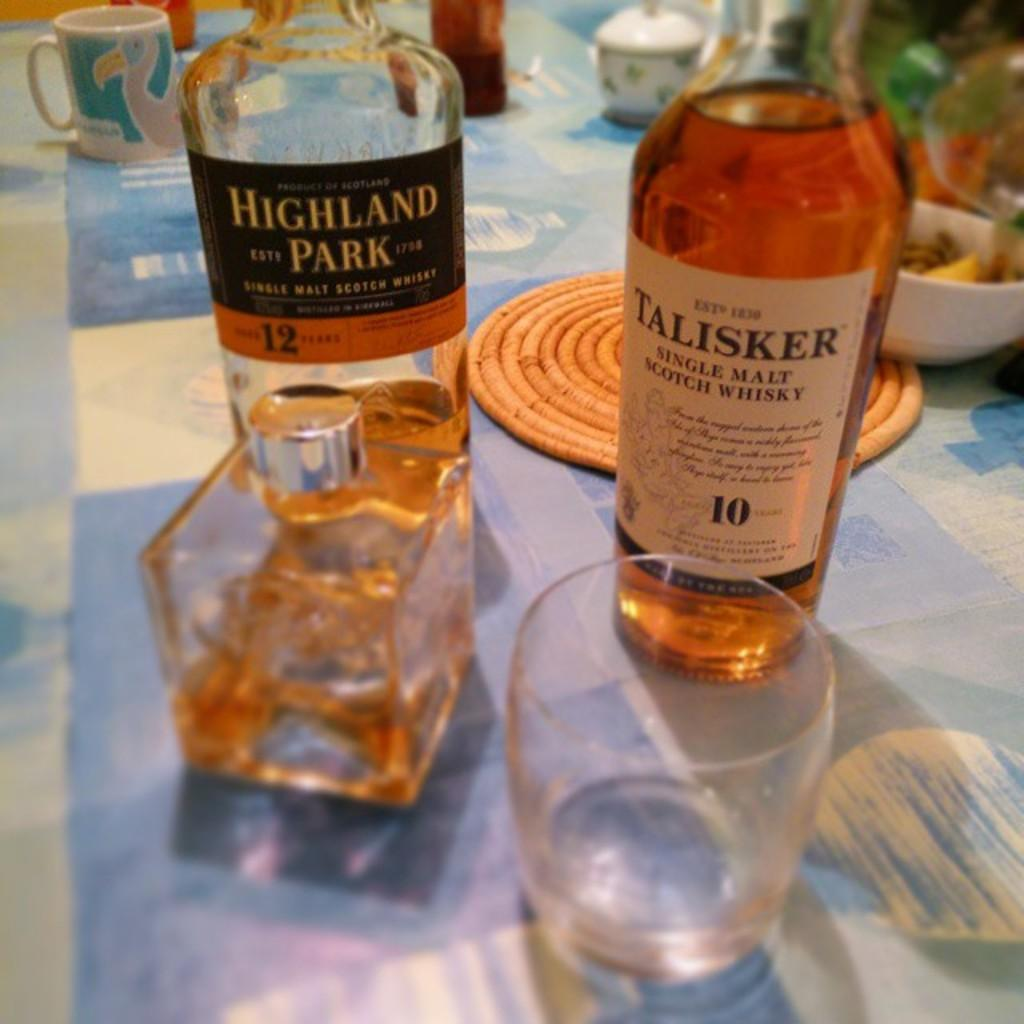<image>
Provide a brief description of the given image. A bottle of Highland Park Malt on a table next to a bottle of Talisker Malt 